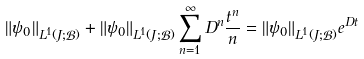Convert formula to latex. <formula><loc_0><loc_0><loc_500><loc_500>\| \psi _ { 0 } \| _ { L ^ { 1 } ( J ; \mathcal { B } ) } + \| \psi _ { 0 } \| _ { L ^ { 1 } ( J ; \mathcal { B } ) } \sum _ { n = 1 } ^ { \infty } D ^ { n } \frac { t ^ { n } } { n } = \| \psi _ { 0 } \| _ { L ^ { 1 } ( J ; \mathcal { B } ) } e ^ { D t }</formula> 